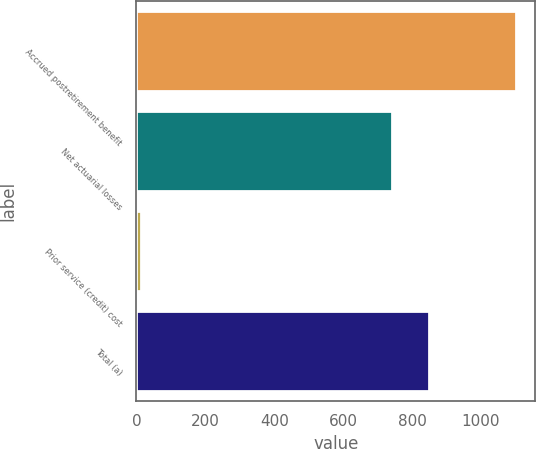<chart> <loc_0><loc_0><loc_500><loc_500><bar_chart><fcel>Accrued postretirement benefit<fcel>Net actuarial losses<fcel>Prior service (credit) cost<fcel>Total (a)<nl><fcel>1102<fcel>741<fcel>14<fcel>849.8<nl></chart> 